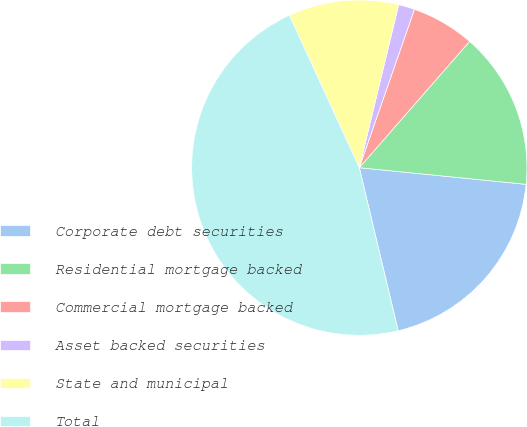Convert chart to OTSL. <chart><loc_0><loc_0><loc_500><loc_500><pie_chart><fcel>Corporate debt securities<fcel>Residential mortgage backed<fcel>Commercial mortgage backed<fcel>Asset backed securities<fcel>State and municipal<fcel>Total<nl><fcel>19.69%<fcel>15.16%<fcel>6.09%<fcel>1.56%<fcel>10.62%<fcel>46.88%<nl></chart> 